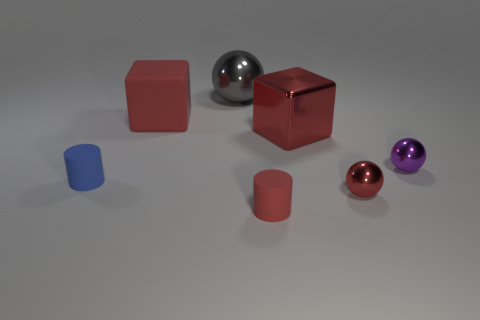The purple ball is what size?
Your response must be concise. Small. Are there fewer red balls that are behind the large red matte object than tiny yellow metallic things?
Provide a succinct answer. No. What number of red shiny balls are the same size as the gray sphere?
Your answer should be very brief. 0. The tiny metallic thing that is the same color as the shiny block is what shape?
Keep it short and to the point. Sphere. There is a tiny rubber thing that is in front of the tiny blue cylinder; is its color the same as the tiny metallic object in front of the blue cylinder?
Offer a very short reply. Yes. There is a big shiny sphere; how many small red cylinders are left of it?
Your answer should be compact. 0. The cylinder that is the same color as the matte block is what size?
Keep it short and to the point. Small. Are there any small red metallic objects of the same shape as the gray object?
Provide a short and direct response. Yes. The other rubber cylinder that is the same size as the blue matte cylinder is what color?
Offer a terse response. Red. Is the number of small red rubber objects that are behind the big gray ball less than the number of large balls that are to the right of the large red rubber cube?
Ensure brevity in your answer.  Yes. 